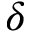<formula> <loc_0><loc_0><loc_500><loc_500>\boldsymbol \delta</formula> 